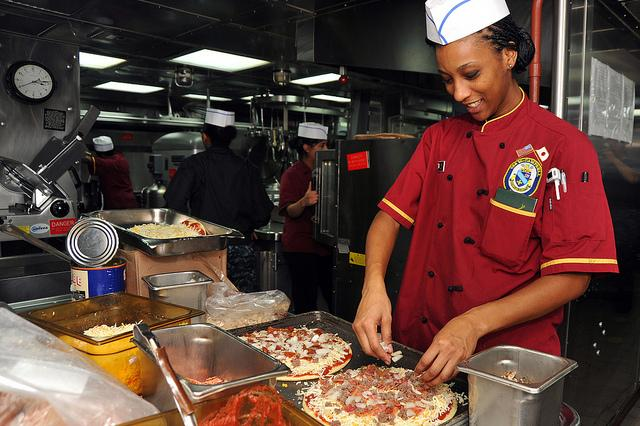What period of the day is it in the image? afternoon 